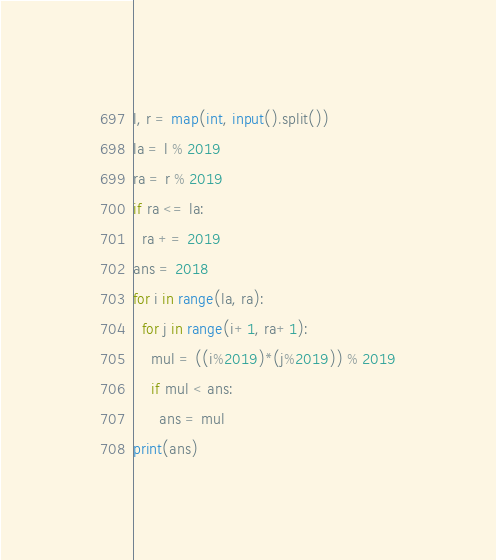<code> <loc_0><loc_0><loc_500><loc_500><_Python_>l, r = map(int, input().split())
la = l % 2019
ra = r % 2019
if ra <= la:
  ra += 2019
ans = 2018
for i in range(la, ra):
  for j in range(i+1, ra+1):
    mul = ((i%2019)*(j%2019)) % 2019
    if mul < ans:
      ans = mul
print(ans)
</code> 